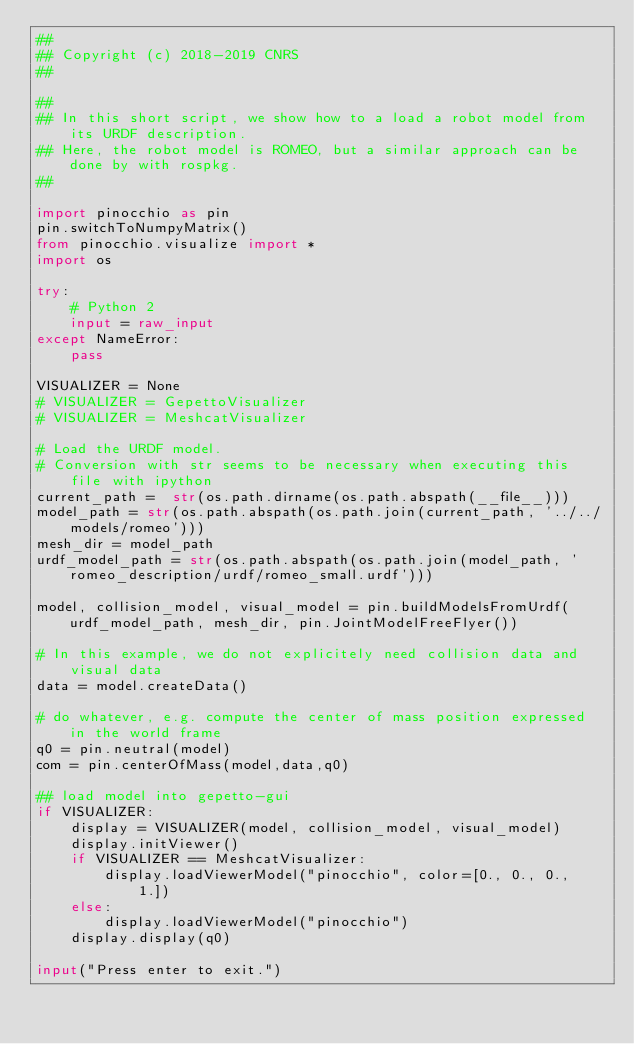Convert code to text. <code><loc_0><loc_0><loc_500><loc_500><_Python_>##
## Copyright (c) 2018-2019 CNRS
##

##
## In this short script, we show how to a load a robot model from its URDF description.
## Here, the robot model is ROMEO, but a similar approach can be done by with rospkg.
##

import pinocchio as pin
pin.switchToNumpyMatrix()
from pinocchio.visualize import *
import os

try:
    # Python 2
    input = raw_input
except NameError:
    pass

VISUALIZER = None
# VISUALIZER = GepettoVisualizer
# VISUALIZER = MeshcatVisualizer

# Load the URDF model.
# Conversion with str seems to be necessary when executing this file with ipython
current_path =  str(os.path.dirname(os.path.abspath(__file__)))
model_path = str(os.path.abspath(os.path.join(current_path, '../../models/romeo')))
mesh_dir = model_path
urdf_model_path = str(os.path.abspath(os.path.join(model_path, 'romeo_description/urdf/romeo_small.urdf')))

model, collision_model, visual_model = pin.buildModelsFromUrdf(urdf_model_path, mesh_dir, pin.JointModelFreeFlyer())

# In this example, we do not explicitely need collision data and visual data
data = model.createData()

# do whatever, e.g. compute the center of mass position expressed in the world frame
q0 = pin.neutral(model)
com = pin.centerOfMass(model,data,q0)

## load model into gepetto-gui
if VISUALIZER:
    display = VISUALIZER(model, collision_model, visual_model)
    display.initViewer()
    if VISUALIZER == MeshcatVisualizer:
        display.loadViewerModel("pinocchio", color=[0., 0., 0., 1.])
    else:
        display.loadViewerModel("pinocchio")
    display.display(q0)

input("Press enter to exit.")
</code> 